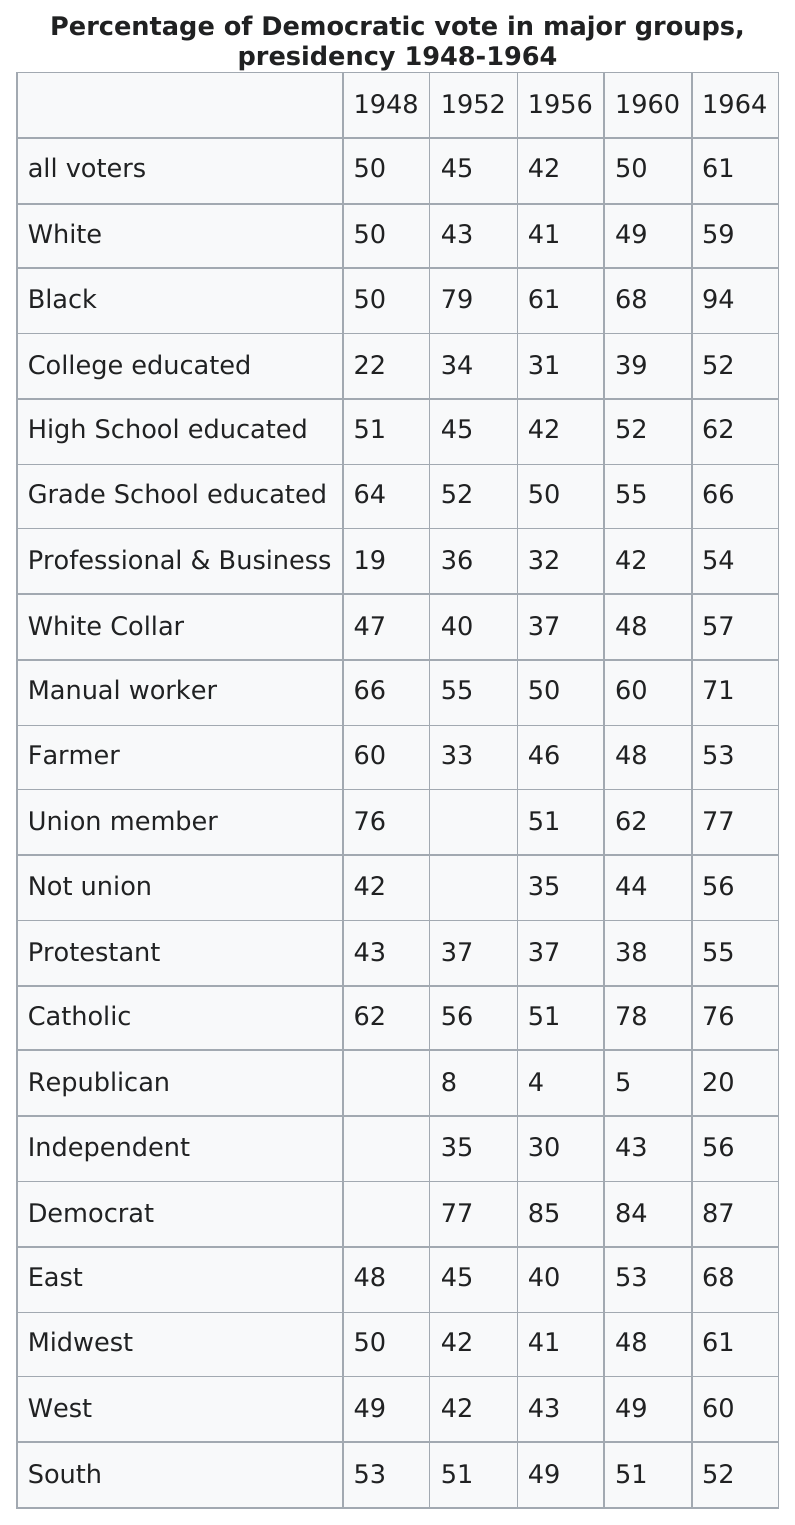Specify some key components in this picture. In the year 1948, 17 groups were listed. In 1964, the group with the most votes was the Black community. The following group of voters is listed as being high school educated: those who have completed grade school education. In 1964, 77% of union member voters who cast their ballots voted for the Democratic Party candidate. In 1956, the white group or the farmer group had the larger percentage. The farmer group had a larger percentage. 